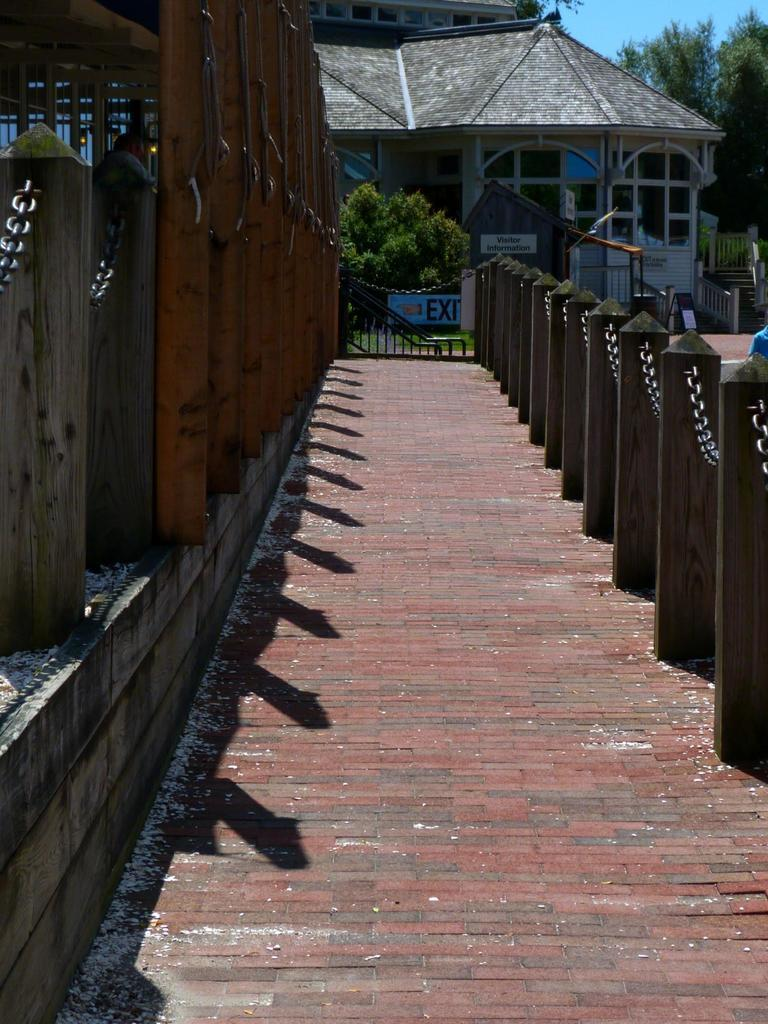What type of structure is visible in the image? There is a house in the image. What objects can be seen near the house? There are boards and chains in the image. What type of natural elements are present in the image? There are trees in the image. What might be a possible route or path in the image? It appears to be a pathway in the image. What is visible in the background of the image? The sky is visible in the background of the image. What type of bomb can be seen in the image? There is no bomb present in the image. What form does the war take in the image? There is no war present in the image; it is a scene featuring a house, boards, chains, trees, a pathway, and the sky. 